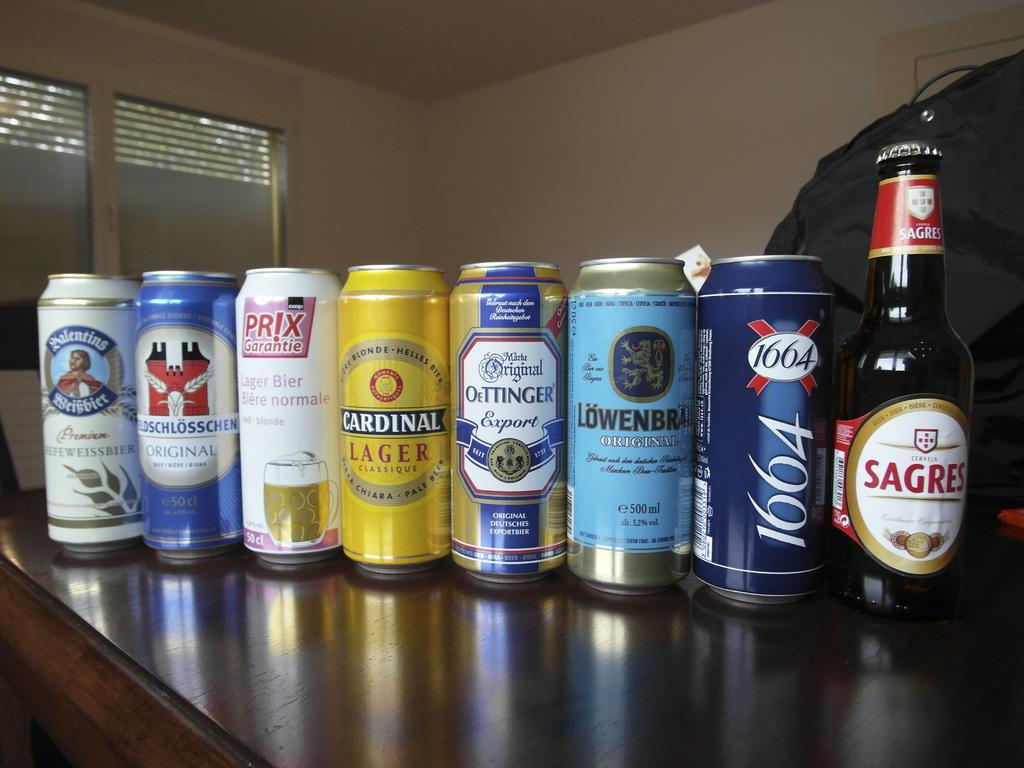Provide a one-sentence caption for the provided image. The collection of cans and bottles includes Cardinal Lager. 